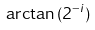Convert formula to latex. <formula><loc_0><loc_0><loc_500><loc_500>\arctan { ( 2 ^ { - i } ) }</formula> 